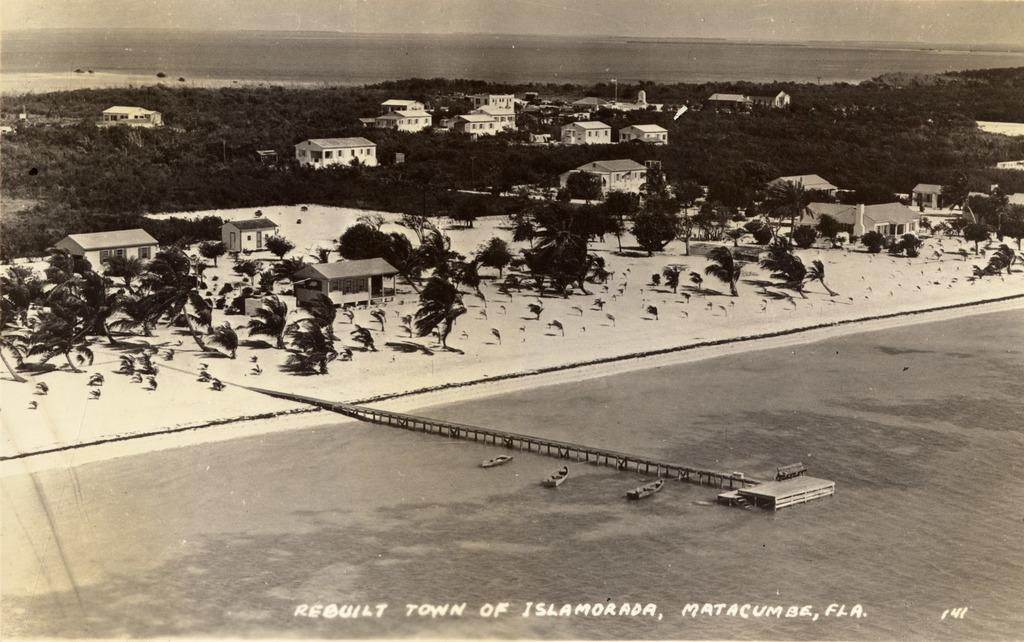<image>
Present a compact description of the photo's key features. Rebuilt town of Islamorada Matacumes Fla. writing in white. 